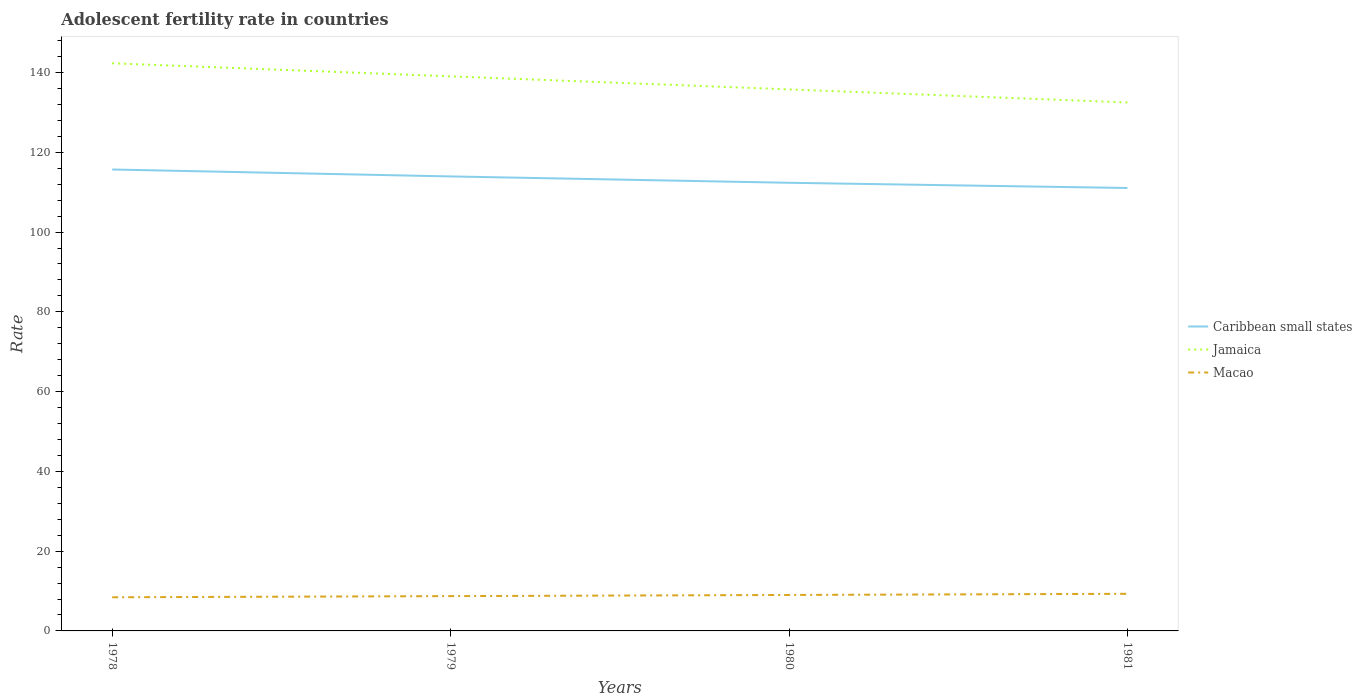How many different coloured lines are there?
Provide a short and direct response. 3. Does the line corresponding to Caribbean small states intersect with the line corresponding to Macao?
Offer a terse response. No. Across all years, what is the maximum adolescent fertility rate in Macao?
Provide a succinct answer. 8.44. In which year was the adolescent fertility rate in Caribbean small states maximum?
Offer a very short reply. 1981. What is the total adolescent fertility rate in Jamaica in the graph?
Make the answer very short. 3.28. What is the difference between the highest and the second highest adolescent fertility rate in Jamaica?
Ensure brevity in your answer.  9.83. Is the adolescent fertility rate in Caribbean small states strictly greater than the adolescent fertility rate in Jamaica over the years?
Your answer should be compact. Yes. How many lines are there?
Ensure brevity in your answer.  3. How many years are there in the graph?
Offer a very short reply. 4. What is the difference between two consecutive major ticks on the Y-axis?
Ensure brevity in your answer.  20. How are the legend labels stacked?
Provide a succinct answer. Vertical. What is the title of the graph?
Your response must be concise. Adolescent fertility rate in countries. Does "Sao Tome and Principe" appear as one of the legend labels in the graph?
Your answer should be very brief. No. What is the label or title of the X-axis?
Make the answer very short. Years. What is the label or title of the Y-axis?
Provide a short and direct response. Rate. What is the Rate of Caribbean small states in 1978?
Give a very brief answer. 115.69. What is the Rate of Jamaica in 1978?
Offer a very short reply. 142.32. What is the Rate of Macao in 1978?
Make the answer very short. 8.44. What is the Rate in Caribbean small states in 1979?
Your response must be concise. 113.95. What is the Rate of Jamaica in 1979?
Your answer should be compact. 139.05. What is the Rate in Macao in 1979?
Your response must be concise. 8.73. What is the Rate of Caribbean small states in 1980?
Give a very brief answer. 112.36. What is the Rate of Jamaica in 1980?
Offer a terse response. 135.77. What is the Rate of Macao in 1980?
Your response must be concise. 9.02. What is the Rate in Caribbean small states in 1981?
Your answer should be very brief. 111.06. What is the Rate in Jamaica in 1981?
Make the answer very short. 132.5. What is the Rate in Macao in 1981?
Provide a short and direct response. 9.31. Across all years, what is the maximum Rate of Caribbean small states?
Offer a terse response. 115.69. Across all years, what is the maximum Rate in Jamaica?
Give a very brief answer. 142.32. Across all years, what is the maximum Rate of Macao?
Offer a very short reply. 9.31. Across all years, what is the minimum Rate of Caribbean small states?
Your answer should be compact. 111.06. Across all years, what is the minimum Rate of Jamaica?
Your response must be concise. 132.5. Across all years, what is the minimum Rate in Macao?
Make the answer very short. 8.44. What is the total Rate of Caribbean small states in the graph?
Ensure brevity in your answer.  453.06. What is the total Rate of Jamaica in the graph?
Offer a terse response. 549.64. What is the total Rate of Macao in the graph?
Ensure brevity in your answer.  35.48. What is the difference between the Rate of Caribbean small states in 1978 and that in 1979?
Make the answer very short. 1.74. What is the difference between the Rate in Jamaica in 1978 and that in 1979?
Provide a short and direct response. 3.28. What is the difference between the Rate in Macao in 1978 and that in 1979?
Provide a short and direct response. -0.29. What is the difference between the Rate of Caribbean small states in 1978 and that in 1980?
Keep it short and to the point. 3.33. What is the difference between the Rate in Jamaica in 1978 and that in 1980?
Give a very brief answer. 6.55. What is the difference between the Rate of Macao in 1978 and that in 1980?
Give a very brief answer. -0.58. What is the difference between the Rate in Caribbean small states in 1978 and that in 1981?
Provide a short and direct response. 4.63. What is the difference between the Rate in Jamaica in 1978 and that in 1981?
Ensure brevity in your answer.  9.83. What is the difference between the Rate of Macao in 1978 and that in 1981?
Make the answer very short. -0.87. What is the difference between the Rate of Caribbean small states in 1979 and that in 1980?
Provide a short and direct response. 1.59. What is the difference between the Rate in Jamaica in 1979 and that in 1980?
Your response must be concise. 3.28. What is the difference between the Rate in Macao in 1979 and that in 1980?
Your answer should be compact. -0.29. What is the difference between the Rate in Caribbean small states in 1979 and that in 1981?
Provide a short and direct response. 2.9. What is the difference between the Rate in Jamaica in 1979 and that in 1981?
Make the answer very short. 6.55. What is the difference between the Rate of Macao in 1979 and that in 1981?
Keep it short and to the point. -0.58. What is the difference between the Rate of Caribbean small states in 1980 and that in 1981?
Your answer should be very brief. 1.31. What is the difference between the Rate of Jamaica in 1980 and that in 1981?
Offer a terse response. 3.28. What is the difference between the Rate in Macao in 1980 and that in 1981?
Offer a terse response. -0.29. What is the difference between the Rate of Caribbean small states in 1978 and the Rate of Jamaica in 1979?
Keep it short and to the point. -23.36. What is the difference between the Rate of Caribbean small states in 1978 and the Rate of Macao in 1979?
Your response must be concise. 106.96. What is the difference between the Rate of Jamaica in 1978 and the Rate of Macao in 1979?
Your response must be concise. 133.6. What is the difference between the Rate in Caribbean small states in 1978 and the Rate in Jamaica in 1980?
Your response must be concise. -20.08. What is the difference between the Rate of Caribbean small states in 1978 and the Rate of Macao in 1980?
Your response must be concise. 106.67. What is the difference between the Rate of Jamaica in 1978 and the Rate of Macao in 1980?
Provide a short and direct response. 133.31. What is the difference between the Rate of Caribbean small states in 1978 and the Rate of Jamaica in 1981?
Your answer should be very brief. -16.81. What is the difference between the Rate in Caribbean small states in 1978 and the Rate in Macao in 1981?
Offer a very short reply. 106.38. What is the difference between the Rate in Jamaica in 1978 and the Rate in Macao in 1981?
Make the answer very short. 133.02. What is the difference between the Rate of Caribbean small states in 1979 and the Rate of Jamaica in 1980?
Your answer should be compact. -21.82. What is the difference between the Rate in Caribbean small states in 1979 and the Rate in Macao in 1980?
Offer a very short reply. 104.94. What is the difference between the Rate of Jamaica in 1979 and the Rate of Macao in 1980?
Ensure brevity in your answer.  130.03. What is the difference between the Rate of Caribbean small states in 1979 and the Rate of Jamaica in 1981?
Your answer should be compact. -18.54. What is the difference between the Rate of Caribbean small states in 1979 and the Rate of Macao in 1981?
Make the answer very short. 104.65. What is the difference between the Rate of Jamaica in 1979 and the Rate of Macao in 1981?
Your answer should be very brief. 129.74. What is the difference between the Rate in Caribbean small states in 1980 and the Rate in Jamaica in 1981?
Your answer should be very brief. -20.13. What is the difference between the Rate in Caribbean small states in 1980 and the Rate in Macao in 1981?
Provide a succinct answer. 103.06. What is the difference between the Rate in Jamaica in 1980 and the Rate in Macao in 1981?
Your answer should be very brief. 126.47. What is the average Rate in Caribbean small states per year?
Your answer should be very brief. 113.27. What is the average Rate in Jamaica per year?
Your answer should be compact. 137.41. What is the average Rate of Macao per year?
Provide a short and direct response. 8.87. In the year 1978, what is the difference between the Rate of Caribbean small states and Rate of Jamaica?
Your answer should be very brief. -26.64. In the year 1978, what is the difference between the Rate of Caribbean small states and Rate of Macao?
Provide a short and direct response. 107.25. In the year 1978, what is the difference between the Rate of Jamaica and Rate of Macao?
Make the answer very short. 133.89. In the year 1979, what is the difference between the Rate of Caribbean small states and Rate of Jamaica?
Your answer should be very brief. -25.09. In the year 1979, what is the difference between the Rate of Caribbean small states and Rate of Macao?
Keep it short and to the point. 105.23. In the year 1979, what is the difference between the Rate in Jamaica and Rate in Macao?
Ensure brevity in your answer.  130.32. In the year 1980, what is the difference between the Rate of Caribbean small states and Rate of Jamaica?
Your response must be concise. -23.41. In the year 1980, what is the difference between the Rate of Caribbean small states and Rate of Macao?
Provide a short and direct response. 103.35. In the year 1980, what is the difference between the Rate of Jamaica and Rate of Macao?
Keep it short and to the point. 126.76. In the year 1981, what is the difference between the Rate of Caribbean small states and Rate of Jamaica?
Offer a terse response. -21.44. In the year 1981, what is the difference between the Rate of Caribbean small states and Rate of Macao?
Make the answer very short. 101.75. In the year 1981, what is the difference between the Rate of Jamaica and Rate of Macao?
Your response must be concise. 123.19. What is the ratio of the Rate in Caribbean small states in 1978 to that in 1979?
Provide a short and direct response. 1.02. What is the ratio of the Rate in Jamaica in 1978 to that in 1979?
Provide a short and direct response. 1.02. What is the ratio of the Rate of Macao in 1978 to that in 1979?
Ensure brevity in your answer.  0.97. What is the ratio of the Rate of Caribbean small states in 1978 to that in 1980?
Give a very brief answer. 1.03. What is the ratio of the Rate in Jamaica in 1978 to that in 1980?
Give a very brief answer. 1.05. What is the ratio of the Rate in Macao in 1978 to that in 1980?
Offer a terse response. 0.94. What is the ratio of the Rate in Caribbean small states in 1978 to that in 1981?
Make the answer very short. 1.04. What is the ratio of the Rate of Jamaica in 1978 to that in 1981?
Give a very brief answer. 1.07. What is the ratio of the Rate of Macao in 1978 to that in 1981?
Your response must be concise. 0.91. What is the ratio of the Rate of Caribbean small states in 1979 to that in 1980?
Keep it short and to the point. 1.01. What is the ratio of the Rate of Jamaica in 1979 to that in 1980?
Keep it short and to the point. 1.02. What is the ratio of the Rate in Macao in 1979 to that in 1980?
Ensure brevity in your answer.  0.97. What is the ratio of the Rate in Caribbean small states in 1979 to that in 1981?
Provide a succinct answer. 1.03. What is the ratio of the Rate of Jamaica in 1979 to that in 1981?
Offer a very short reply. 1.05. What is the ratio of the Rate of Macao in 1979 to that in 1981?
Ensure brevity in your answer.  0.94. What is the ratio of the Rate in Caribbean small states in 1980 to that in 1981?
Your answer should be very brief. 1.01. What is the ratio of the Rate of Jamaica in 1980 to that in 1981?
Offer a very short reply. 1.02. What is the ratio of the Rate in Macao in 1980 to that in 1981?
Make the answer very short. 0.97. What is the difference between the highest and the second highest Rate in Caribbean small states?
Provide a succinct answer. 1.74. What is the difference between the highest and the second highest Rate in Jamaica?
Give a very brief answer. 3.28. What is the difference between the highest and the second highest Rate in Macao?
Make the answer very short. 0.29. What is the difference between the highest and the lowest Rate of Caribbean small states?
Provide a short and direct response. 4.63. What is the difference between the highest and the lowest Rate of Jamaica?
Provide a short and direct response. 9.83. What is the difference between the highest and the lowest Rate of Macao?
Your response must be concise. 0.87. 